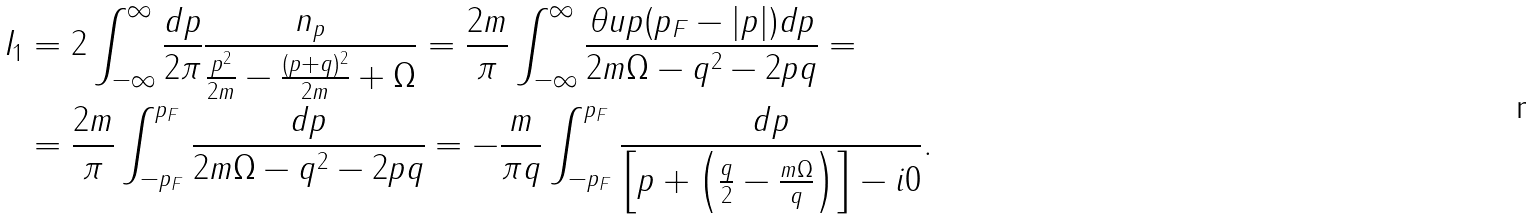<formula> <loc_0><loc_0><loc_500><loc_500>I _ { 1 } & = 2 \int _ { - \infty } ^ { \infty } \frac { d p } { 2 \pi } \frac { n _ { p } } { \frac { p ^ { 2 } } { 2 m } - \frac { ( p + q ) ^ { 2 } } { 2 m } + \Omega } = \frac { 2 m } { \pi } \int _ { - \infty } ^ { \infty } \frac { \theta u p ( p _ { F } - | p | ) d p } { 2 m \Omega - q ^ { 2 } - 2 p q } = \\ & = \frac { 2 m } { \pi } \int _ { - p _ { F } } ^ { p _ { F } } \frac { d p } { 2 m \Omega - q ^ { 2 } - 2 p q } = - \frac { m } { \pi q } \int _ { - p _ { F } } ^ { p _ { F } } \frac { d p } { \left [ p + \left ( \frac { q } { 2 } - \frac { m \Omega } { q } \right ) \right ] - i 0 } .</formula> 